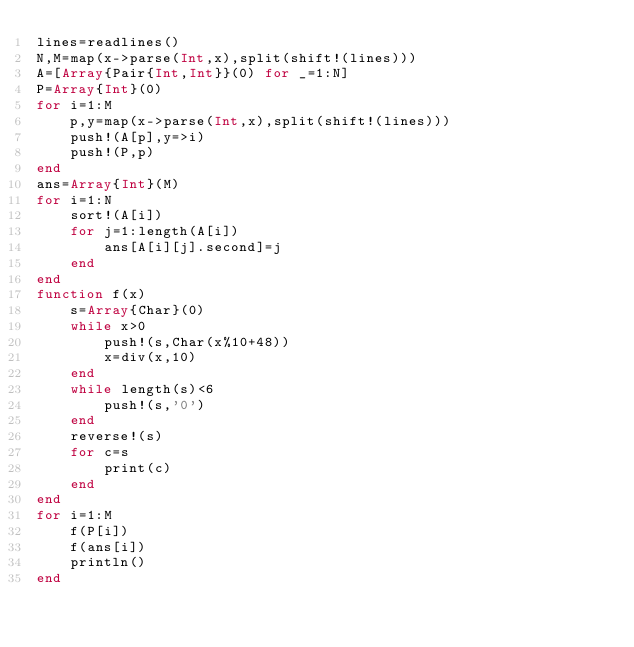<code> <loc_0><loc_0><loc_500><loc_500><_Julia_>lines=readlines()
N,M=map(x->parse(Int,x),split(shift!(lines)))
A=[Array{Pair{Int,Int}}(0) for _=1:N]
P=Array{Int}(0)
for i=1:M
	p,y=map(x->parse(Int,x),split(shift!(lines)))
	push!(A[p],y=>i)
	push!(P,p)
end
ans=Array{Int}(M)
for i=1:N
	sort!(A[i])
	for j=1:length(A[i])
		ans[A[i][j].second]=j
	end
end
function f(x)
	s=Array{Char}(0)
	while x>0
		push!(s,Char(x%10+48))
		x=div(x,10)
	end
	while length(s)<6
		push!(s,'0')
	end
	reverse!(s)
	for c=s
		print(c)
	end
end
for i=1:M
	f(P[i])
	f(ans[i])
	println()
end
</code> 